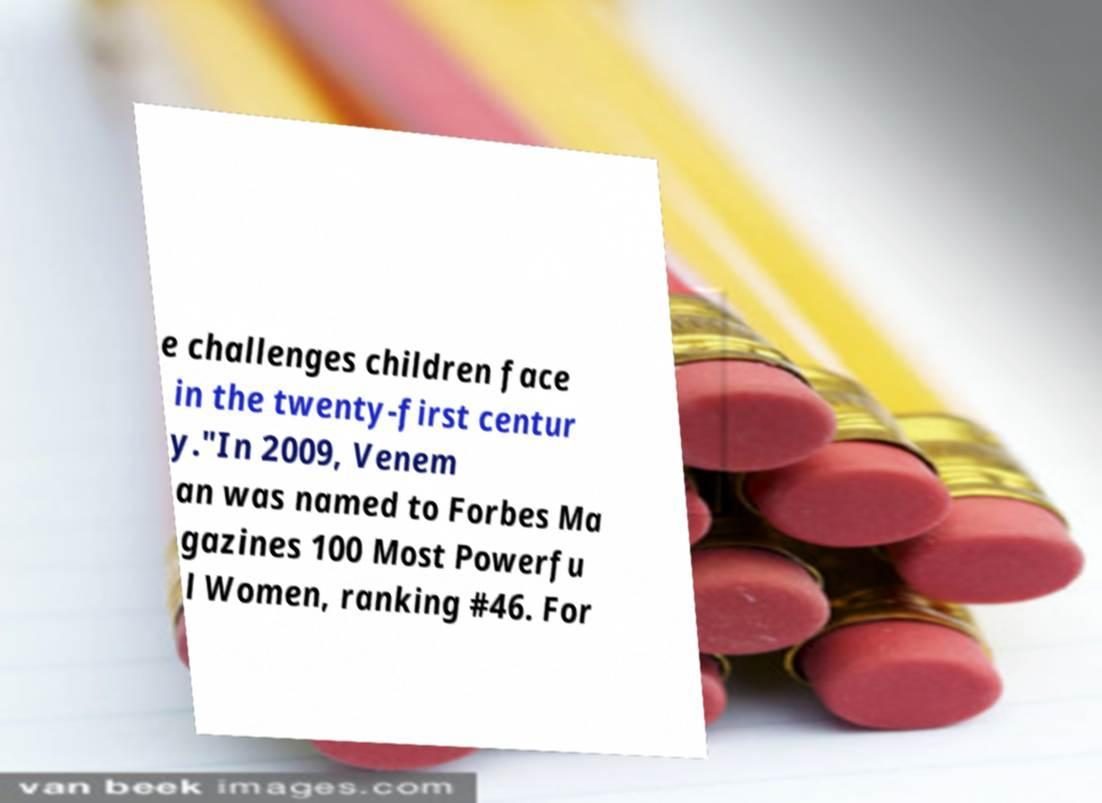Please read and relay the text visible in this image. What does it say? e challenges children face in the twenty-first centur y."In 2009, Venem an was named to Forbes Ma gazines 100 Most Powerfu l Women, ranking #46. For 